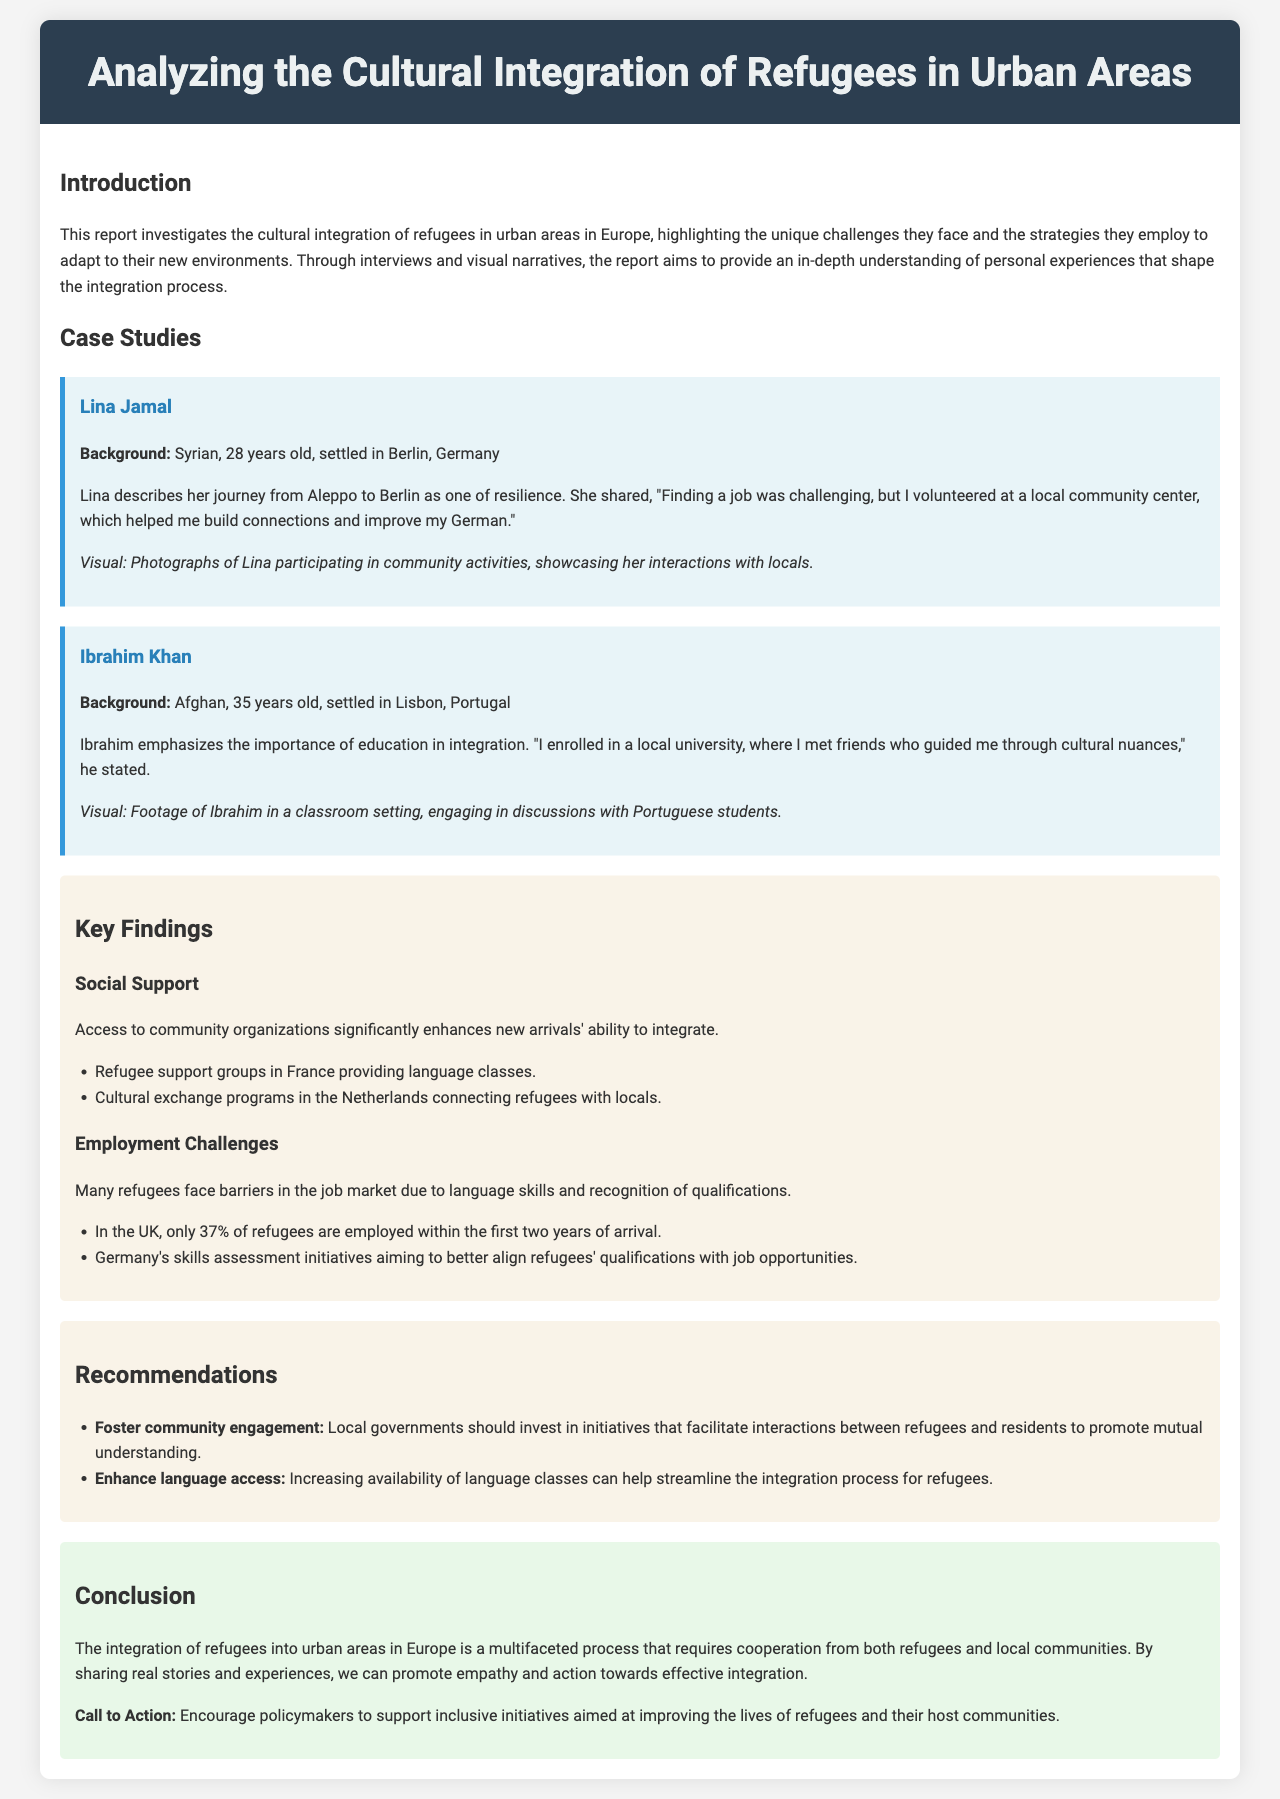what is the main focus of the report? The report investigates the cultural integration of refugees in urban areas in Europe.
Answer: cultural integration of refugees who is featured as a case study from Berlin? Lina Jamal is presented as a case study inhabiting Berlin.
Answer: Lina Jamal what percentage of refugees are employed in the UK within two years? The report states that only 37% of refugees are employed within the first two years of arrival in the UK.
Answer: 37% what strategy did Ibrahim Khan employ for integration? Ibrahim Khan emphasized the importance of enrolling in a local university for his integration process.
Answer: education what is a recommendation for fostering integration? One of the recommendations is for local governments to invest in initiatives that facilitate interactions between refugees and residents.
Answer: foster community engagement how does Lina Jamal connect with the local community? Lina connected with the local community by volunteering at a community center.
Answer: volunteering 